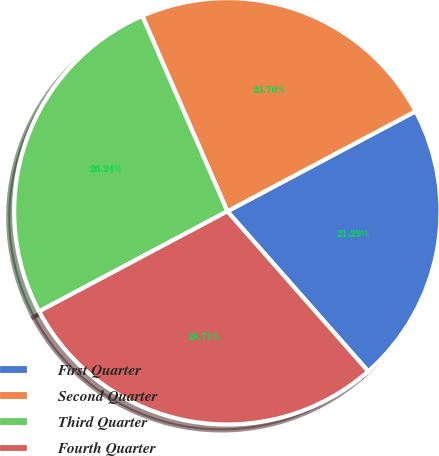<chart> <loc_0><loc_0><loc_500><loc_500><pie_chart><fcel>First Quarter<fcel>Second Quarter<fcel>Third Quarter<fcel>Fourth Quarter<nl><fcel>21.29%<fcel>23.76%<fcel>26.24%<fcel>28.71%<nl></chart> 